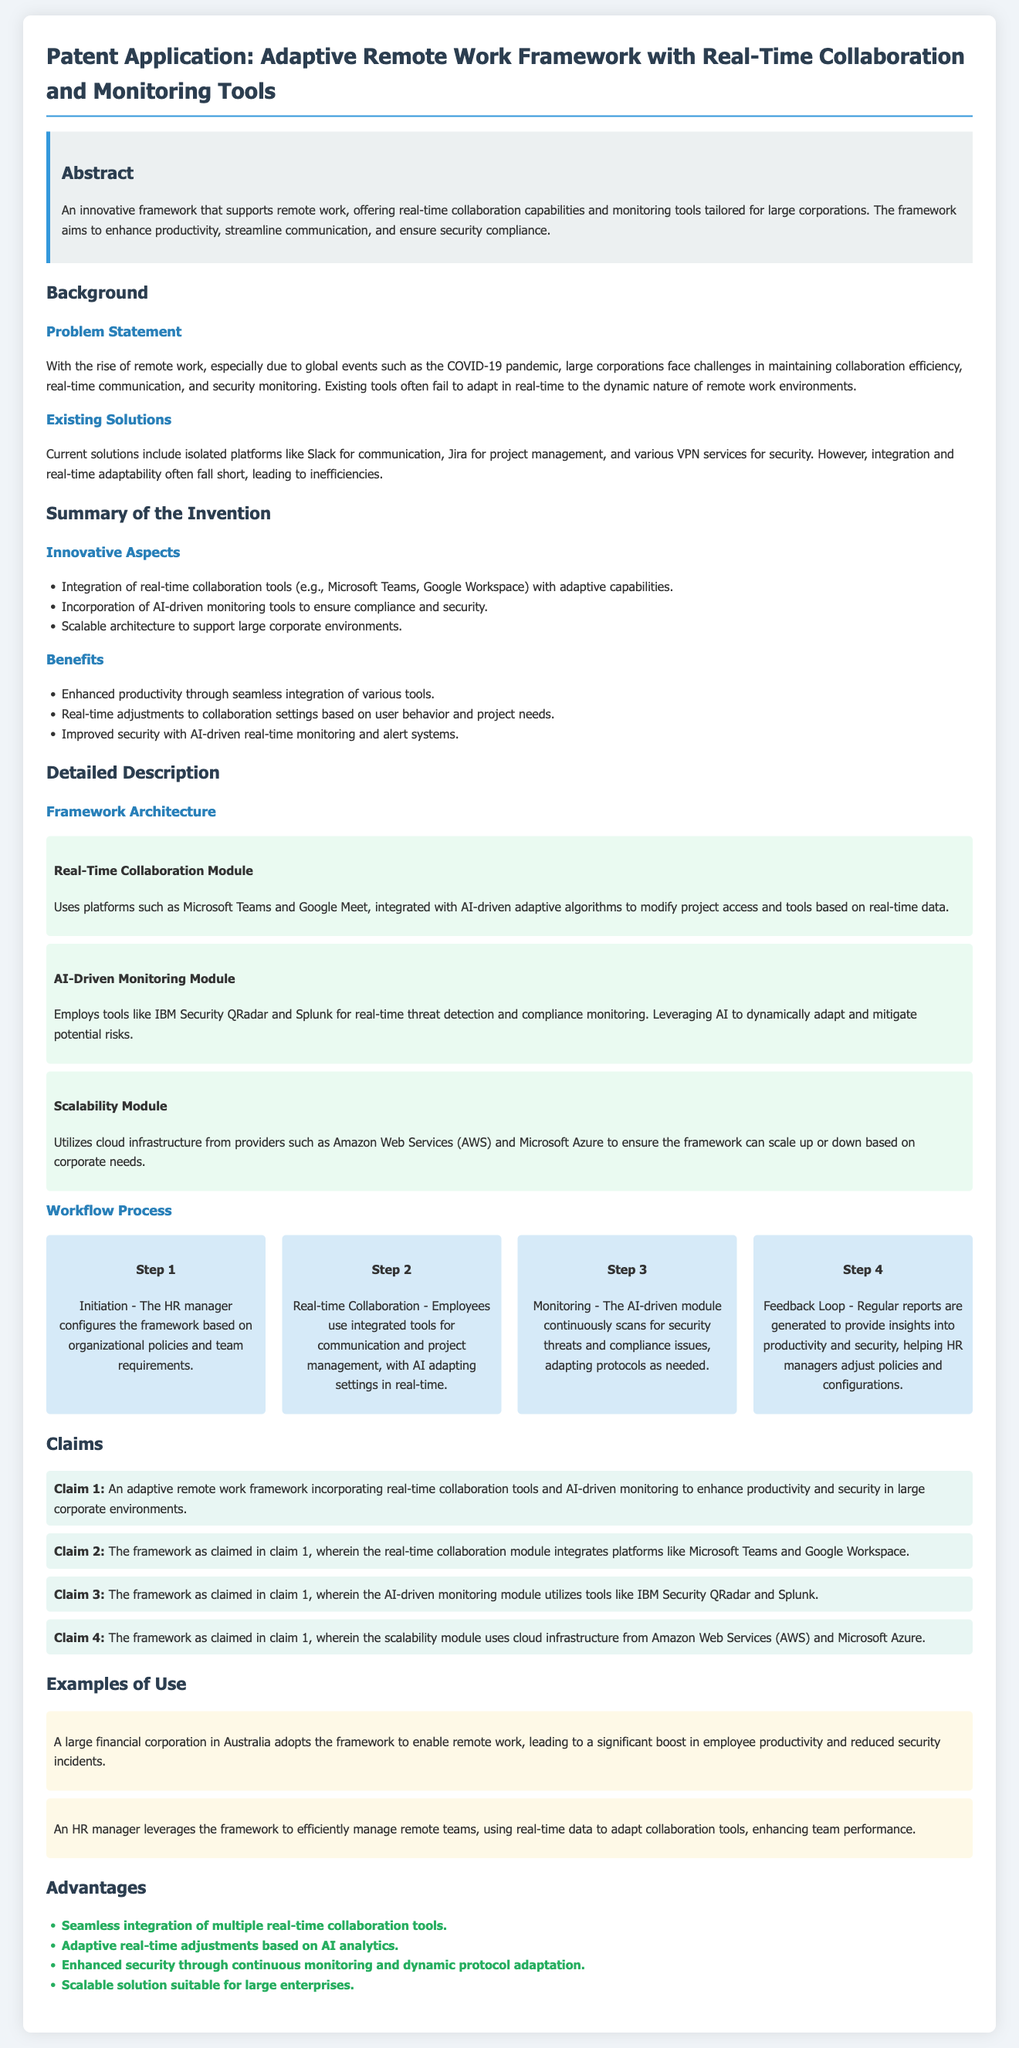what is the title of the patent application? The title is presented prominently at the beginning of the document, indicating the subject matter of the application.
Answer: Adaptive Remote Work Framework with Real-Time Collaboration and Monitoring Tools what are the key problems addressed in the background section? The problem statement outlines specific challenges faced by corporations due to remote work dynamics, which are stated in the document.
Answer: Maintaining collaboration efficiency, real-time communication, and security monitoring which platforms are integrated within the real-time collaboration module? The document specifies the platforms used within the framework for collaboration, highlighting their importance.
Answer: Microsoft Teams, Google Meet how does the AI-driven monitoring module ensure compliance? The document explains the function of the AI-driven monitoring module in relation to compliance monitoring.
Answer: Real-time threat detection and compliance monitoring what is the main benefit of the framework regarding security? The benefits section outlines advantages of the framework, particularly focusing on security improvements.
Answer: Improved security with AI-driven real-time monitoring and alert systems which companies provide the cloud infrastructure for scalability? The scalability module mentions specific providers who help in maintaining the framework's architecture.
Answer: Amazon Web Services, Microsoft Azure how many steps are involved in the workflow process? The number of steps in the workflow process can be counted based on the provided section in the document.
Answer: Four what is a specific example of how the framework is used? The examples section gives practical applications of the framework within corporate settings, demonstrating its use.
Answer: A large financial corporation in Australia adopts the framework to enable remote work what is the document type? The introduction of the document categorizes its content, which is typical for legal or inventive submissions.
Answer: Patent Application 